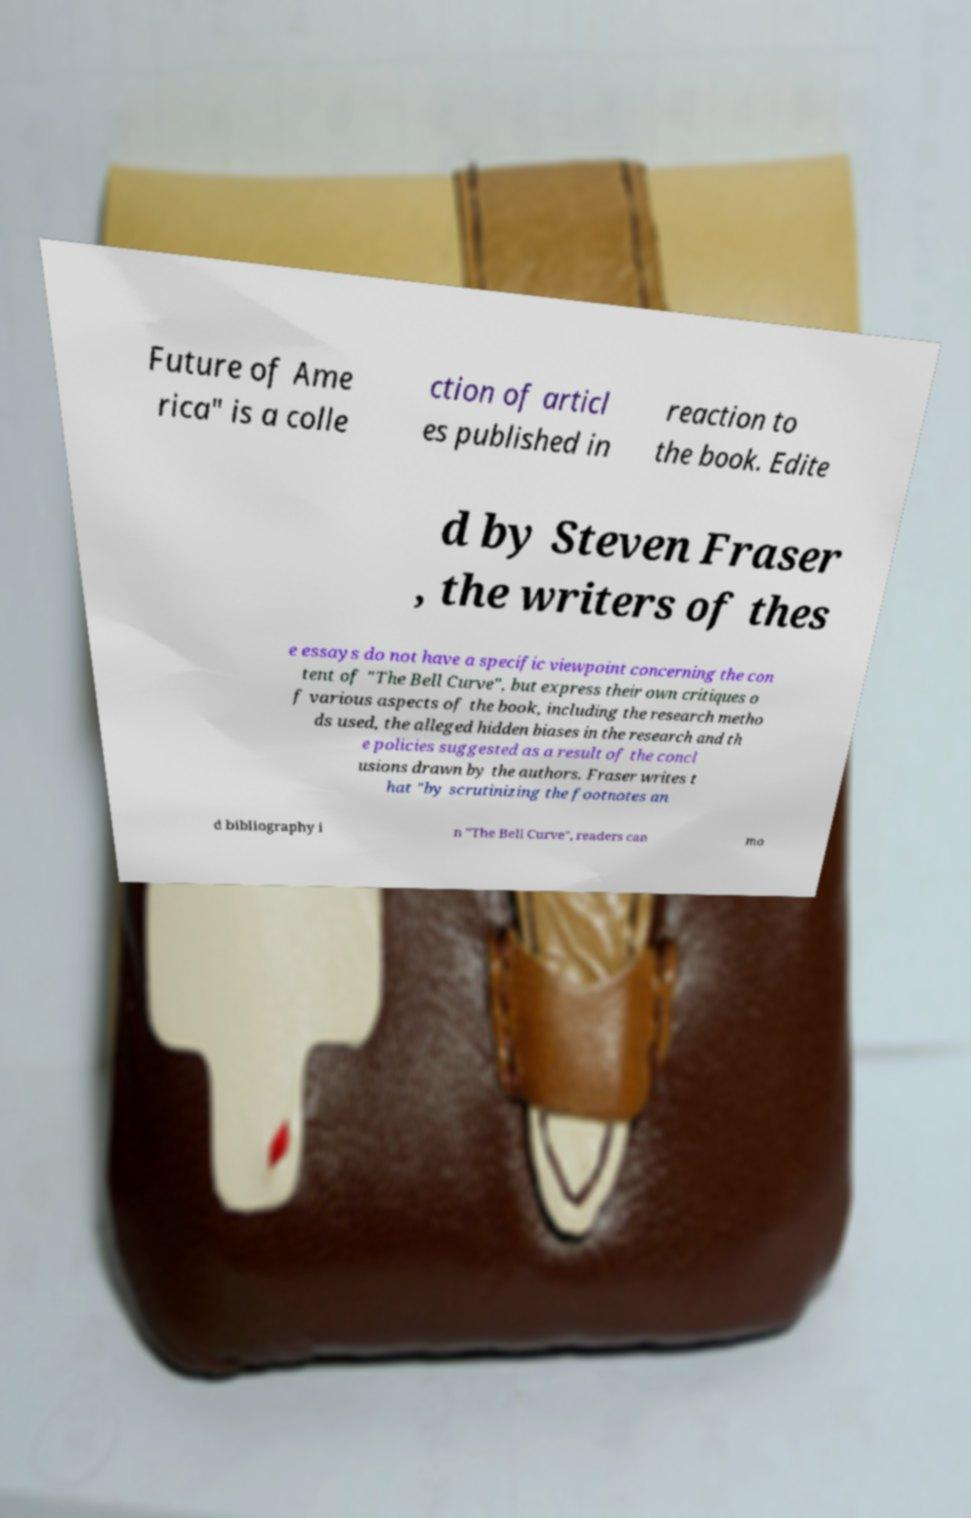Can you accurately transcribe the text from the provided image for me? Future of Ame rica" is a colle ction of articl es published in reaction to the book. Edite d by Steven Fraser , the writers of thes e essays do not have a specific viewpoint concerning the con tent of "The Bell Curve", but express their own critiques o f various aspects of the book, including the research metho ds used, the alleged hidden biases in the research and th e policies suggested as a result of the concl usions drawn by the authors. Fraser writes t hat "by scrutinizing the footnotes an d bibliography i n "The Bell Curve", readers can mo 